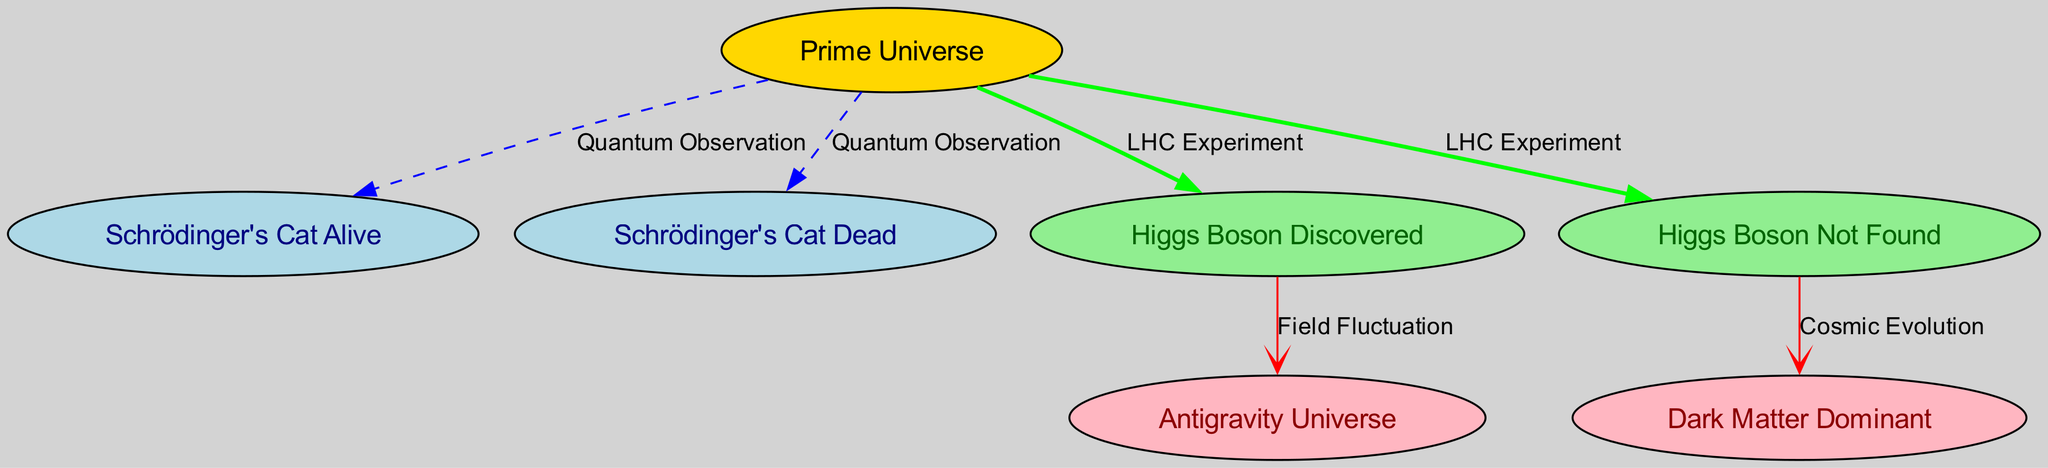What is the label of the starting node? The starting node is labeled "Prime Universe," as identified as the first node in the diagram's structure.
Answer: Prime Universe How many nodes are in the diagram? The diagram contains a total of 7 nodes, as counted from the node list provided in the data.
Answer: 7 Which node represents the outcome when Higgs Boson is found? The node that represents the outcome when Higgs Boson is discovered is "Higgs Boson Discovered," which is connected to further nodes based on the research findings.
Answer: Higgs Boson Discovered What type of edge connects "Prime Universe" and "Schrödinger's Cat Dead"? The edge connecting "Prime Universe" and "Schrödinger's Cat Dead" is labeled "Quantum Observation," indicated by the edge description in the data.
Answer: Quantum Observation What is the relationship between "Higgs Boson Not Found" and "Dark Matter Dominant"? The relationship is marked by the edge labeled "Cosmic Evolution," which transitions the flow from "Higgs Boson Not Found" to "Dark Matter Dominant."
Answer: Cosmic Evolution Which node is connected to "Higgs Boson Discovered"? The node connected to "Higgs Boson Discovered" is "Antigravity Universe," which flows from the outcome of the Higgs Boson discovery.
Answer: Antigravity Universe How many edges originate from "Prime Universe"? There are 4 edges originating from "Prime Universe," as seen in the outgoing connections listed in the diagram's edges data.
Answer: 4 What color is the node for "Schrödinger's Cat Alive"? The node for "Schrödinger's Cat Alive" is colored light blue, as specified in the diagram's node attributes.
Answer: Light Blue What happens in the "Antigravity Universe"? In the "Antigravity Universe," it is reached through "Higgs Boson Discovered" as a consequence of field fluctuation in the universe research context.
Answer: Field Fluctuation 